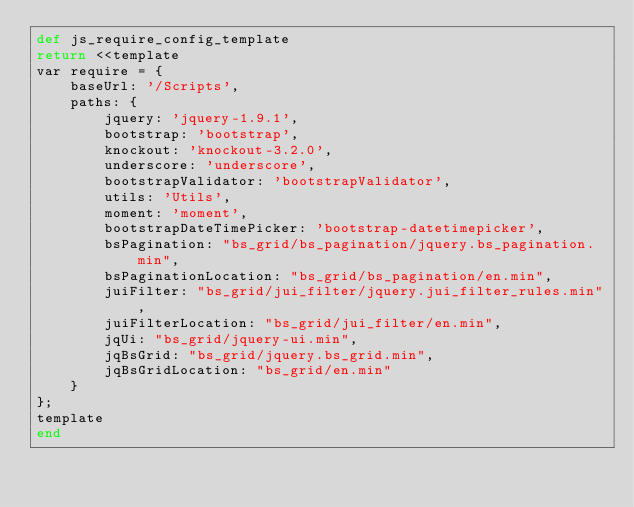<code> <loc_0><loc_0><loc_500><loc_500><_Ruby_>def js_require_config_template
return <<template
var require = {
    baseUrl: '/Scripts',
    paths: {
        jquery: 'jquery-1.9.1',
        bootstrap: 'bootstrap',
        knockout: 'knockout-3.2.0',
        underscore: 'underscore',
        bootstrapValidator: 'bootstrapValidator',
        utils: 'Utils',
        moment: 'moment',
        bootstrapDateTimePicker: 'bootstrap-datetimepicker',
        bsPagination: "bs_grid/bs_pagination/jquery.bs_pagination.min",
        bsPaginationLocation: "bs_grid/bs_pagination/en.min",
        juiFilter: "bs_grid/jui_filter/jquery.jui_filter_rules.min",
        juiFilterLocation: "bs_grid/jui_filter/en.min",
        jqUi: "bs_grid/jquery-ui.min",
        jqBsGrid: "bs_grid/jquery.bs_grid.min",
        jqBsGridLocation: "bs_grid/en.min"
    }
};
template
end</code> 